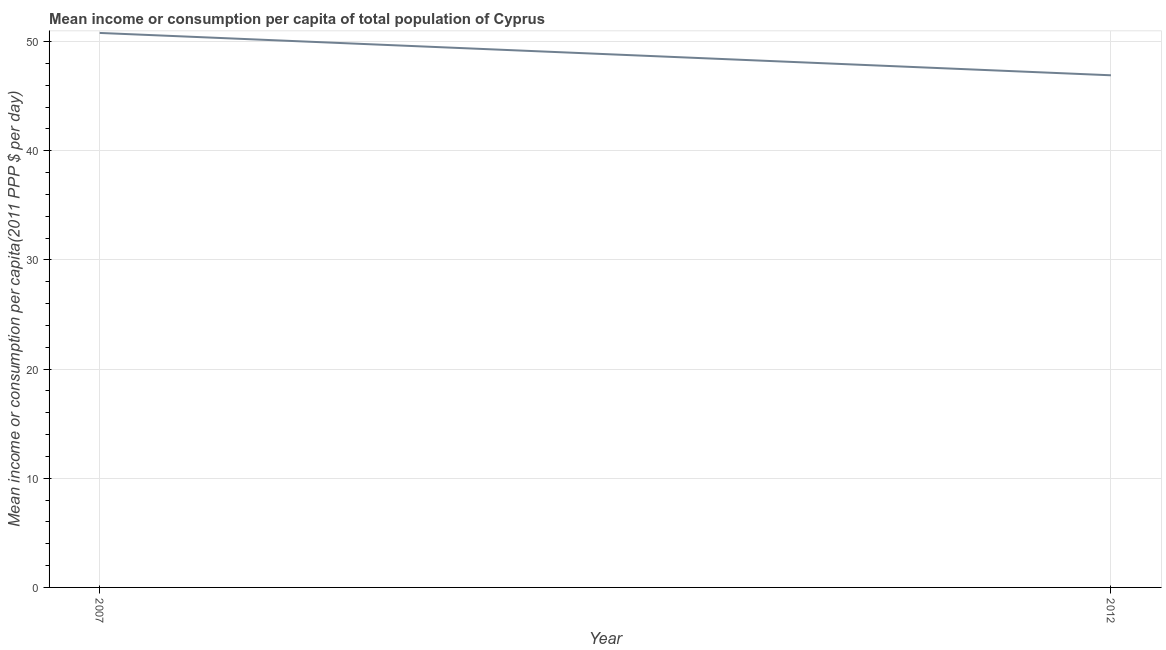What is the mean income or consumption in 2007?
Ensure brevity in your answer.  50.79. Across all years, what is the maximum mean income or consumption?
Provide a succinct answer. 50.79. Across all years, what is the minimum mean income or consumption?
Your answer should be compact. 46.91. In which year was the mean income or consumption maximum?
Offer a very short reply. 2007. What is the sum of the mean income or consumption?
Your response must be concise. 97.7. What is the difference between the mean income or consumption in 2007 and 2012?
Offer a very short reply. 3.88. What is the average mean income or consumption per year?
Keep it short and to the point. 48.85. What is the median mean income or consumption?
Your answer should be very brief. 48.85. Do a majority of the years between 2012 and 2007 (inclusive) have mean income or consumption greater than 12 $?
Keep it short and to the point. No. What is the ratio of the mean income or consumption in 2007 to that in 2012?
Provide a succinct answer. 1.08. In how many years, is the mean income or consumption greater than the average mean income or consumption taken over all years?
Offer a very short reply. 1. How many lines are there?
Ensure brevity in your answer.  1. How many years are there in the graph?
Give a very brief answer. 2. What is the difference between two consecutive major ticks on the Y-axis?
Give a very brief answer. 10. Are the values on the major ticks of Y-axis written in scientific E-notation?
Your response must be concise. No. What is the title of the graph?
Provide a succinct answer. Mean income or consumption per capita of total population of Cyprus. What is the label or title of the Y-axis?
Provide a short and direct response. Mean income or consumption per capita(2011 PPP $ per day). What is the Mean income or consumption per capita(2011 PPP $ per day) of 2007?
Your response must be concise. 50.79. What is the Mean income or consumption per capita(2011 PPP $ per day) in 2012?
Your answer should be very brief. 46.91. What is the difference between the Mean income or consumption per capita(2011 PPP $ per day) in 2007 and 2012?
Ensure brevity in your answer.  3.88. What is the ratio of the Mean income or consumption per capita(2011 PPP $ per day) in 2007 to that in 2012?
Offer a terse response. 1.08. 